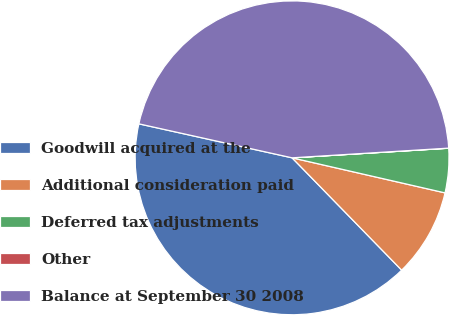<chart> <loc_0><loc_0><loc_500><loc_500><pie_chart><fcel>Goodwill acquired at the<fcel>Additional consideration paid<fcel>Deferred tax adjustments<fcel>Other<fcel>Balance at September 30 2008<nl><fcel>40.78%<fcel>9.11%<fcel>4.56%<fcel>0.01%<fcel>45.54%<nl></chart> 